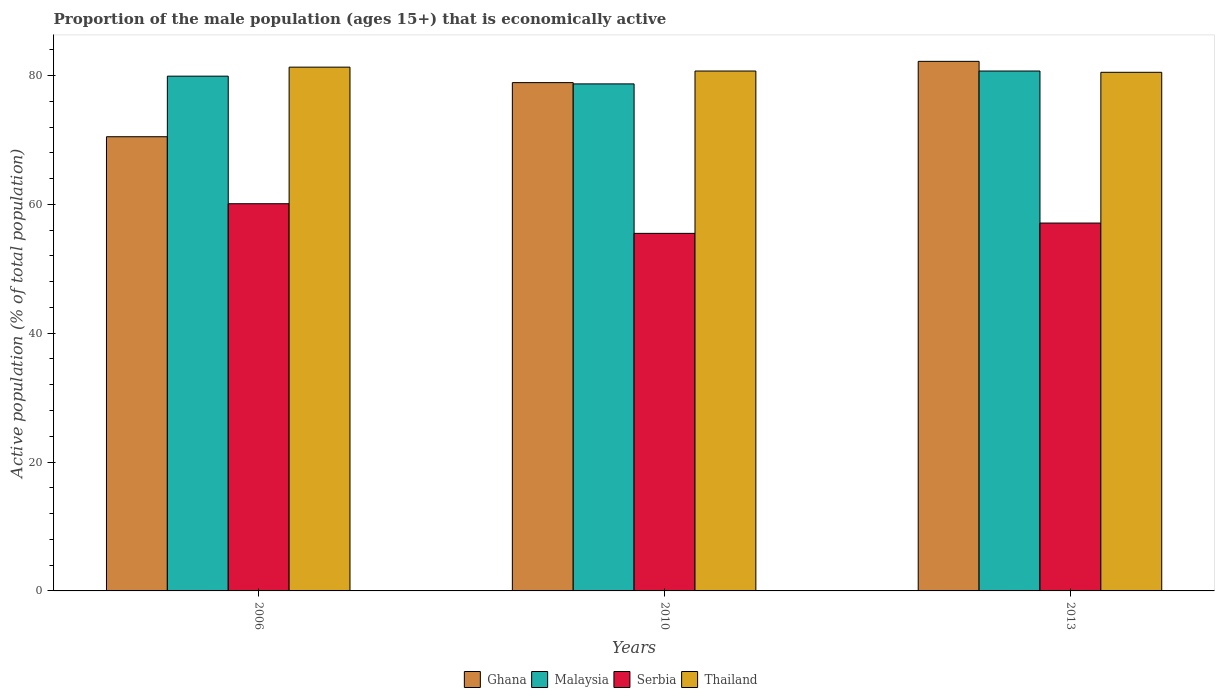How many different coloured bars are there?
Your answer should be compact. 4. How many groups of bars are there?
Your answer should be very brief. 3. Are the number of bars per tick equal to the number of legend labels?
Give a very brief answer. Yes. Are the number of bars on each tick of the X-axis equal?
Provide a succinct answer. Yes. How many bars are there on the 2nd tick from the right?
Keep it short and to the point. 4. What is the label of the 2nd group of bars from the left?
Ensure brevity in your answer.  2010. What is the proportion of the male population that is economically active in Malaysia in 2006?
Make the answer very short. 79.9. Across all years, what is the maximum proportion of the male population that is economically active in Ghana?
Offer a terse response. 82.2. Across all years, what is the minimum proportion of the male population that is economically active in Malaysia?
Give a very brief answer. 78.7. In which year was the proportion of the male population that is economically active in Thailand maximum?
Provide a succinct answer. 2006. In which year was the proportion of the male population that is economically active in Thailand minimum?
Keep it short and to the point. 2013. What is the total proportion of the male population that is economically active in Malaysia in the graph?
Offer a very short reply. 239.3. What is the difference between the proportion of the male population that is economically active in Serbia in 2010 and that in 2013?
Provide a succinct answer. -1.6. What is the difference between the proportion of the male population that is economically active in Serbia in 2010 and the proportion of the male population that is economically active in Malaysia in 2006?
Make the answer very short. -24.4. What is the average proportion of the male population that is economically active in Malaysia per year?
Keep it short and to the point. 79.77. In the year 2010, what is the difference between the proportion of the male population that is economically active in Malaysia and proportion of the male population that is economically active in Ghana?
Ensure brevity in your answer.  -0.2. In how many years, is the proportion of the male population that is economically active in Malaysia greater than 48 %?
Make the answer very short. 3. What is the ratio of the proportion of the male population that is economically active in Thailand in 2010 to that in 2013?
Provide a short and direct response. 1. Is the difference between the proportion of the male population that is economically active in Malaysia in 2006 and 2013 greater than the difference between the proportion of the male population that is economically active in Ghana in 2006 and 2013?
Keep it short and to the point. Yes. What is the difference between the highest and the second highest proportion of the male population that is economically active in Thailand?
Offer a terse response. 0.6. What is the difference between the highest and the lowest proportion of the male population that is economically active in Thailand?
Provide a short and direct response. 0.8. Is it the case that in every year, the sum of the proportion of the male population that is economically active in Ghana and proportion of the male population that is economically active in Serbia is greater than the sum of proportion of the male population that is economically active in Thailand and proportion of the male population that is economically active in Malaysia?
Keep it short and to the point. No. What does the 2nd bar from the left in 2006 represents?
Offer a very short reply. Malaysia. What does the 3rd bar from the right in 2010 represents?
Ensure brevity in your answer.  Malaysia. How many bars are there?
Ensure brevity in your answer.  12. Are all the bars in the graph horizontal?
Your answer should be very brief. No. How many years are there in the graph?
Provide a succinct answer. 3. Are the values on the major ticks of Y-axis written in scientific E-notation?
Provide a succinct answer. No. Does the graph contain any zero values?
Offer a very short reply. No. Does the graph contain grids?
Offer a terse response. No. Where does the legend appear in the graph?
Your response must be concise. Bottom center. How many legend labels are there?
Your response must be concise. 4. How are the legend labels stacked?
Offer a terse response. Horizontal. What is the title of the graph?
Provide a short and direct response. Proportion of the male population (ages 15+) that is economically active. What is the label or title of the Y-axis?
Provide a short and direct response. Active population (% of total population). What is the Active population (% of total population) of Ghana in 2006?
Your answer should be very brief. 70.5. What is the Active population (% of total population) in Malaysia in 2006?
Provide a succinct answer. 79.9. What is the Active population (% of total population) in Serbia in 2006?
Your answer should be very brief. 60.1. What is the Active population (% of total population) of Thailand in 2006?
Your answer should be compact. 81.3. What is the Active population (% of total population) of Ghana in 2010?
Make the answer very short. 78.9. What is the Active population (% of total population) in Malaysia in 2010?
Provide a succinct answer. 78.7. What is the Active population (% of total population) in Serbia in 2010?
Provide a succinct answer. 55.5. What is the Active population (% of total population) in Thailand in 2010?
Offer a terse response. 80.7. What is the Active population (% of total population) of Ghana in 2013?
Make the answer very short. 82.2. What is the Active population (% of total population) in Malaysia in 2013?
Offer a very short reply. 80.7. What is the Active population (% of total population) in Serbia in 2013?
Offer a very short reply. 57.1. What is the Active population (% of total population) of Thailand in 2013?
Your response must be concise. 80.5. Across all years, what is the maximum Active population (% of total population) of Ghana?
Make the answer very short. 82.2. Across all years, what is the maximum Active population (% of total population) of Malaysia?
Give a very brief answer. 80.7. Across all years, what is the maximum Active population (% of total population) of Serbia?
Your answer should be compact. 60.1. Across all years, what is the maximum Active population (% of total population) of Thailand?
Provide a succinct answer. 81.3. Across all years, what is the minimum Active population (% of total population) of Ghana?
Give a very brief answer. 70.5. Across all years, what is the minimum Active population (% of total population) in Malaysia?
Your answer should be very brief. 78.7. Across all years, what is the minimum Active population (% of total population) in Serbia?
Provide a succinct answer. 55.5. Across all years, what is the minimum Active population (% of total population) of Thailand?
Provide a short and direct response. 80.5. What is the total Active population (% of total population) of Ghana in the graph?
Your response must be concise. 231.6. What is the total Active population (% of total population) in Malaysia in the graph?
Your answer should be very brief. 239.3. What is the total Active population (% of total population) in Serbia in the graph?
Keep it short and to the point. 172.7. What is the total Active population (% of total population) of Thailand in the graph?
Provide a succinct answer. 242.5. What is the difference between the Active population (% of total population) in Ghana in 2006 and that in 2010?
Your answer should be compact. -8.4. What is the difference between the Active population (% of total population) of Malaysia in 2006 and that in 2010?
Your answer should be very brief. 1.2. What is the difference between the Active population (% of total population) of Malaysia in 2006 and that in 2013?
Make the answer very short. -0.8. What is the difference between the Active population (% of total population) of Serbia in 2006 and that in 2013?
Make the answer very short. 3. What is the difference between the Active population (% of total population) in Thailand in 2006 and that in 2013?
Offer a very short reply. 0.8. What is the difference between the Active population (% of total population) in Serbia in 2010 and that in 2013?
Keep it short and to the point. -1.6. What is the difference between the Active population (% of total population) in Thailand in 2010 and that in 2013?
Keep it short and to the point. 0.2. What is the difference between the Active population (% of total population) in Ghana in 2006 and the Active population (% of total population) in Malaysia in 2010?
Offer a terse response. -8.2. What is the difference between the Active population (% of total population) in Ghana in 2006 and the Active population (% of total population) in Serbia in 2010?
Give a very brief answer. 15. What is the difference between the Active population (% of total population) of Ghana in 2006 and the Active population (% of total population) of Thailand in 2010?
Give a very brief answer. -10.2. What is the difference between the Active population (% of total population) of Malaysia in 2006 and the Active population (% of total population) of Serbia in 2010?
Provide a succinct answer. 24.4. What is the difference between the Active population (% of total population) in Serbia in 2006 and the Active population (% of total population) in Thailand in 2010?
Your answer should be compact. -20.6. What is the difference between the Active population (% of total population) of Ghana in 2006 and the Active population (% of total population) of Malaysia in 2013?
Give a very brief answer. -10.2. What is the difference between the Active population (% of total population) of Malaysia in 2006 and the Active population (% of total population) of Serbia in 2013?
Offer a terse response. 22.8. What is the difference between the Active population (% of total population) of Malaysia in 2006 and the Active population (% of total population) of Thailand in 2013?
Ensure brevity in your answer.  -0.6. What is the difference between the Active population (% of total population) in Serbia in 2006 and the Active population (% of total population) in Thailand in 2013?
Your response must be concise. -20.4. What is the difference between the Active population (% of total population) of Ghana in 2010 and the Active population (% of total population) of Serbia in 2013?
Provide a succinct answer. 21.8. What is the difference between the Active population (% of total population) of Ghana in 2010 and the Active population (% of total population) of Thailand in 2013?
Offer a terse response. -1.6. What is the difference between the Active population (% of total population) in Malaysia in 2010 and the Active population (% of total population) in Serbia in 2013?
Ensure brevity in your answer.  21.6. What is the difference between the Active population (% of total population) of Serbia in 2010 and the Active population (% of total population) of Thailand in 2013?
Provide a short and direct response. -25. What is the average Active population (% of total population) of Ghana per year?
Offer a very short reply. 77.2. What is the average Active population (% of total population) of Malaysia per year?
Your answer should be compact. 79.77. What is the average Active population (% of total population) of Serbia per year?
Your answer should be very brief. 57.57. What is the average Active population (% of total population) in Thailand per year?
Offer a terse response. 80.83. In the year 2006, what is the difference between the Active population (% of total population) of Ghana and Active population (% of total population) of Malaysia?
Ensure brevity in your answer.  -9.4. In the year 2006, what is the difference between the Active population (% of total population) of Ghana and Active population (% of total population) of Serbia?
Your answer should be very brief. 10.4. In the year 2006, what is the difference between the Active population (% of total population) in Ghana and Active population (% of total population) in Thailand?
Your answer should be compact. -10.8. In the year 2006, what is the difference between the Active population (% of total population) of Malaysia and Active population (% of total population) of Serbia?
Provide a short and direct response. 19.8. In the year 2006, what is the difference between the Active population (% of total population) of Malaysia and Active population (% of total population) of Thailand?
Provide a succinct answer. -1.4. In the year 2006, what is the difference between the Active population (% of total population) of Serbia and Active population (% of total population) of Thailand?
Make the answer very short. -21.2. In the year 2010, what is the difference between the Active population (% of total population) in Ghana and Active population (% of total population) in Malaysia?
Give a very brief answer. 0.2. In the year 2010, what is the difference between the Active population (% of total population) of Ghana and Active population (% of total population) of Serbia?
Ensure brevity in your answer.  23.4. In the year 2010, what is the difference between the Active population (% of total population) of Ghana and Active population (% of total population) of Thailand?
Keep it short and to the point. -1.8. In the year 2010, what is the difference between the Active population (% of total population) of Malaysia and Active population (% of total population) of Serbia?
Offer a terse response. 23.2. In the year 2010, what is the difference between the Active population (% of total population) in Serbia and Active population (% of total population) in Thailand?
Your answer should be very brief. -25.2. In the year 2013, what is the difference between the Active population (% of total population) of Ghana and Active population (% of total population) of Serbia?
Give a very brief answer. 25.1. In the year 2013, what is the difference between the Active population (% of total population) in Malaysia and Active population (% of total population) in Serbia?
Your answer should be compact. 23.6. In the year 2013, what is the difference between the Active population (% of total population) of Serbia and Active population (% of total population) of Thailand?
Your response must be concise. -23.4. What is the ratio of the Active population (% of total population) in Ghana in 2006 to that in 2010?
Give a very brief answer. 0.89. What is the ratio of the Active population (% of total population) in Malaysia in 2006 to that in 2010?
Give a very brief answer. 1.02. What is the ratio of the Active population (% of total population) in Serbia in 2006 to that in 2010?
Your answer should be very brief. 1.08. What is the ratio of the Active population (% of total population) of Thailand in 2006 to that in 2010?
Keep it short and to the point. 1.01. What is the ratio of the Active population (% of total population) of Ghana in 2006 to that in 2013?
Offer a very short reply. 0.86. What is the ratio of the Active population (% of total population) of Malaysia in 2006 to that in 2013?
Give a very brief answer. 0.99. What is the ratio of the Active population (% of total population) in Serbia in 2006 to that in 2013?
Provide a short and direct response. 1.05. What is the ratio of the Active population (% of total population) of Thailand in 2006 to that in 2013?
Offer a terse response. 1.01. What is the ratio of the Active population (% of total population) of Ghana in 2010 to that in 2013?
Ensure brevity in your answer.  0.96. What is the ratio of the Active population (% of total population) in Malaysia in 2010 to that in 2013?
Offer a terse response. 0.98. What is the ratio of the Active population (% of total population) in Serbia in 2010 to that in 2013?
Your answer should be compact. 0.97. What is the ratio of the Active population (% of total population) of Thailand in 2010 to that in 2013?
Offer a terse response. 1. What is the difference between the highest and the second highest Active population (% of total population) of Ghana?
Give a very brief answer. 3.3. What is the difference between the highest and the lowest Active population (% of total population) of Ghana?
Keep it short and to the point. 11.7. What is the difference between the highest and the lowest Active population (% of total population) in Malaysia?
Give a very brief answer. 2. What is the difference between the highest and the lowest Active population (% of total population) of Serbia?
Your response must be concise. 4.6. What is the difference between the highest and the lowest Active population (% of total population) in Thailand?
Offer a very short reply. 0.8. 